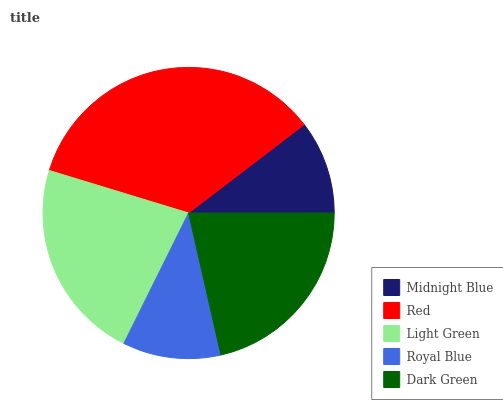Is Midnight Blue the minimum?
Answer yes or no. Yes. Is Red the maximum?
Answer yes or no. Yes. Is Light Green the minimum?
Answer yes or no. No. Is Light Green the maximum?
Answer yes or no. No. Is Red greater than Light Green?
Answer yes or no. Yes. Is Light Green less than Red?
Answer yes or no. Yes. Is Light Green greater than Red?
Answer yes or no. No. Is Red less than Light Green?
Answer yes or no. No. Is Dark Green the high median?
Answer yes or no. Yes. Is Dark Green the low median?
Answer yes or no. Yes. Is Light Green the high median?
Answer yes or no. No. Is Red the low median?
Answer yes or no. No. 